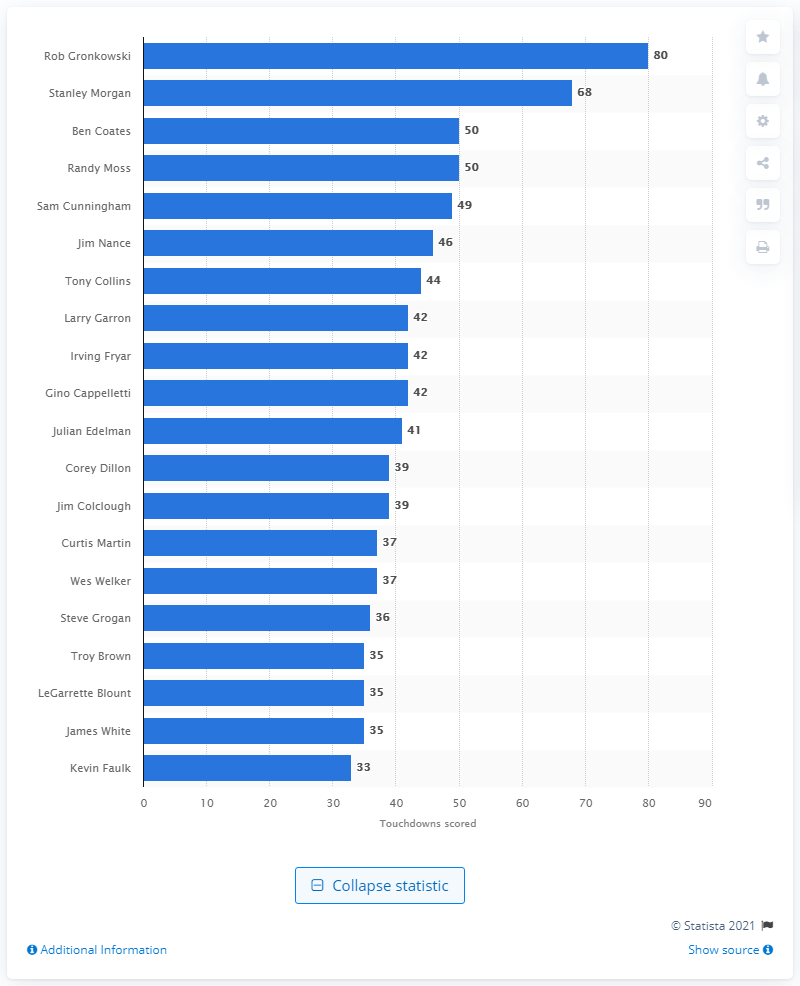List a handful of essential elements in this visual. The career touchdown leader of the New England Patriots is Rob Gronkowski. 